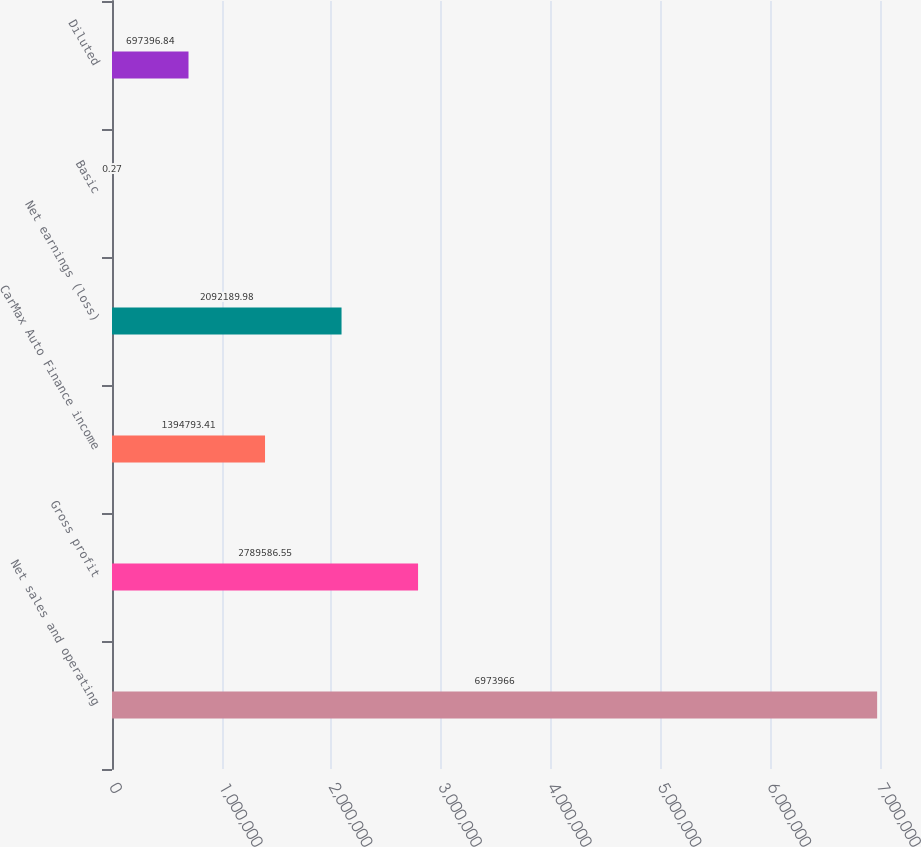Convert chart to OTSL. <chart><loc_0><loc_0><loc_500><loc_500><bar_chart><fcel>Net sales and operating<fcel>Gross profit<fcel>CarMax Auto Finance income<fcel>Net earnings (loss)<fcel>Basic<fcel>Diluted<nl><fcel>6.97397e+06<fcel>2.78959e+06<fcel>1.39479e+06<fcel>2.09219e+06<fcel>0.27<fcel>697397<nl></chart> 